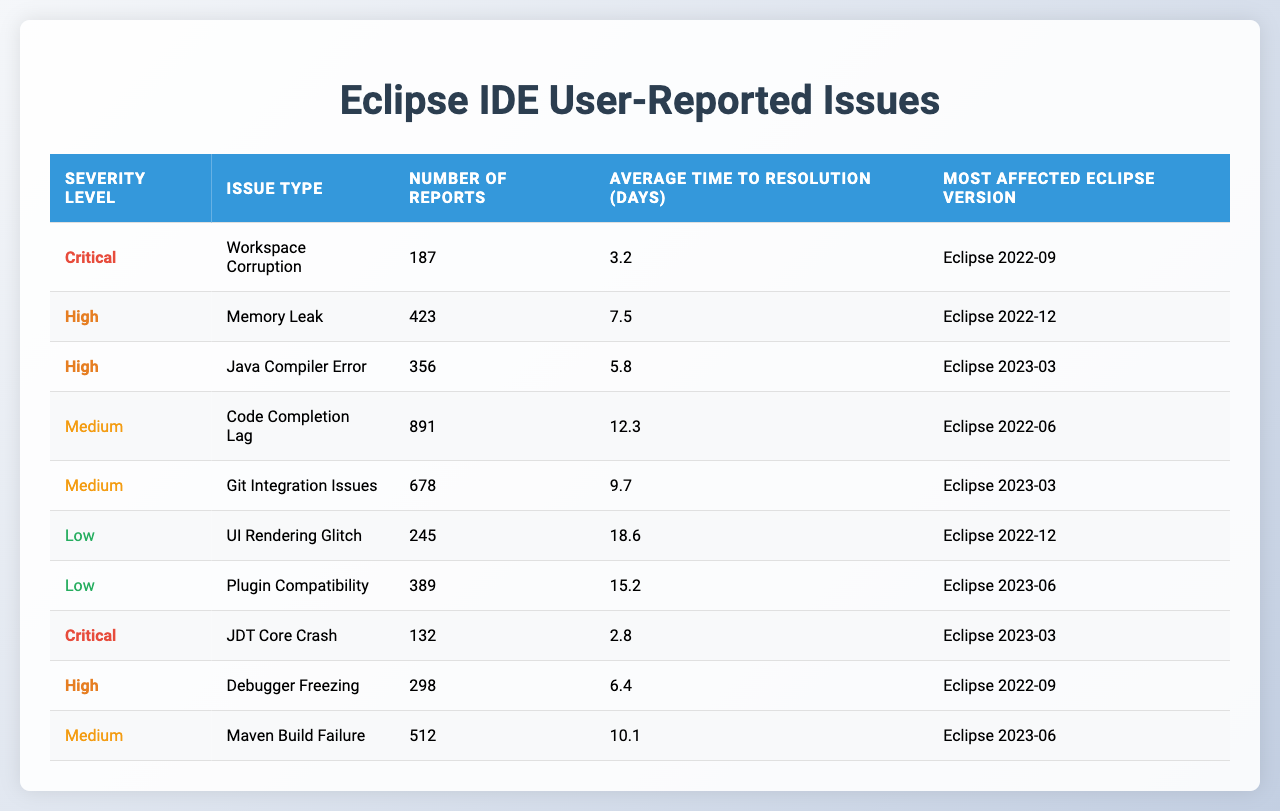What is the most reported issue in the Eclipse IDE? The table shows that the "Code Completion Lag" is the issue with the highest number of reports, which is 891.
Answer: Code Completion Lag How many critical issues were reported? There are two critical issues listed: "Workspace Corruption" (187 reports) and "JDT Core Crash" (132 reports), which totals 319 reports.
Answer: 319 What is the average time to resolve medium severity issues? The average time to resolution for medium severity issues is calculated by taking the average of the given times: (12.3 + 9.7 + 10.1) / 3 = 10.73 days.
Answer: 10.73 days Which issue type has the lowest number of reports? Upon examining the table, "JDT Core Crash" has the lowest number of reports with 132.
Answer: JDT Core Crash Is there a high severity issue that also has a resolution time under 7 days? Yes, the "Debugger Freezing" issue has 298 reports and a resolution time of 6.4 days, which confirms it is both high severity and has a resolution time under 7 days.
Answer: Yes What is the total number of reports for issues classified as low severity? The total number of reports for low severity issues is calculated by summing the reports: 245 (UI Rendering Glitch) + 389 (Plugin Compatibility) = 634.
Answer: 634 For which Eclipse version was the highest number of medium severity issues reported? The version with the most medium severity reports is "Eclipse 2023-03," which includes both "Git Integration Issues" (678 reports) and "Java Compiler Error" (356 reports), making a total of 1034 reports.
Answer: Eclipse 2023-03 What is the difference in average resolution time between critical and high severity issues? The average resolution time for critical issues is (3.2 + 2.8) / 2 = 3.0 days, and for high severity issues, it is (7.5 + 5.8 + 6.4) / 3 = 6.3 days. The difference is 6.3 - 3.0 = 3.3 days.
Answer: 3.3 days How many issues reported in Eclipse 2022-12 are of high severity? The table shows that the only high severity issue listed for Eclipse 2022-12 is "Memory Leak," which has 423 reports. Therefore, there is one high severity issue in that version.
Answer: 1 What is the total number of reports across all levels of severity for the issue type "Git Integration Issues"? There is only one report for "Git Integration Issues," which is 678, as this issue type appears once in the table.
Answer: 678 